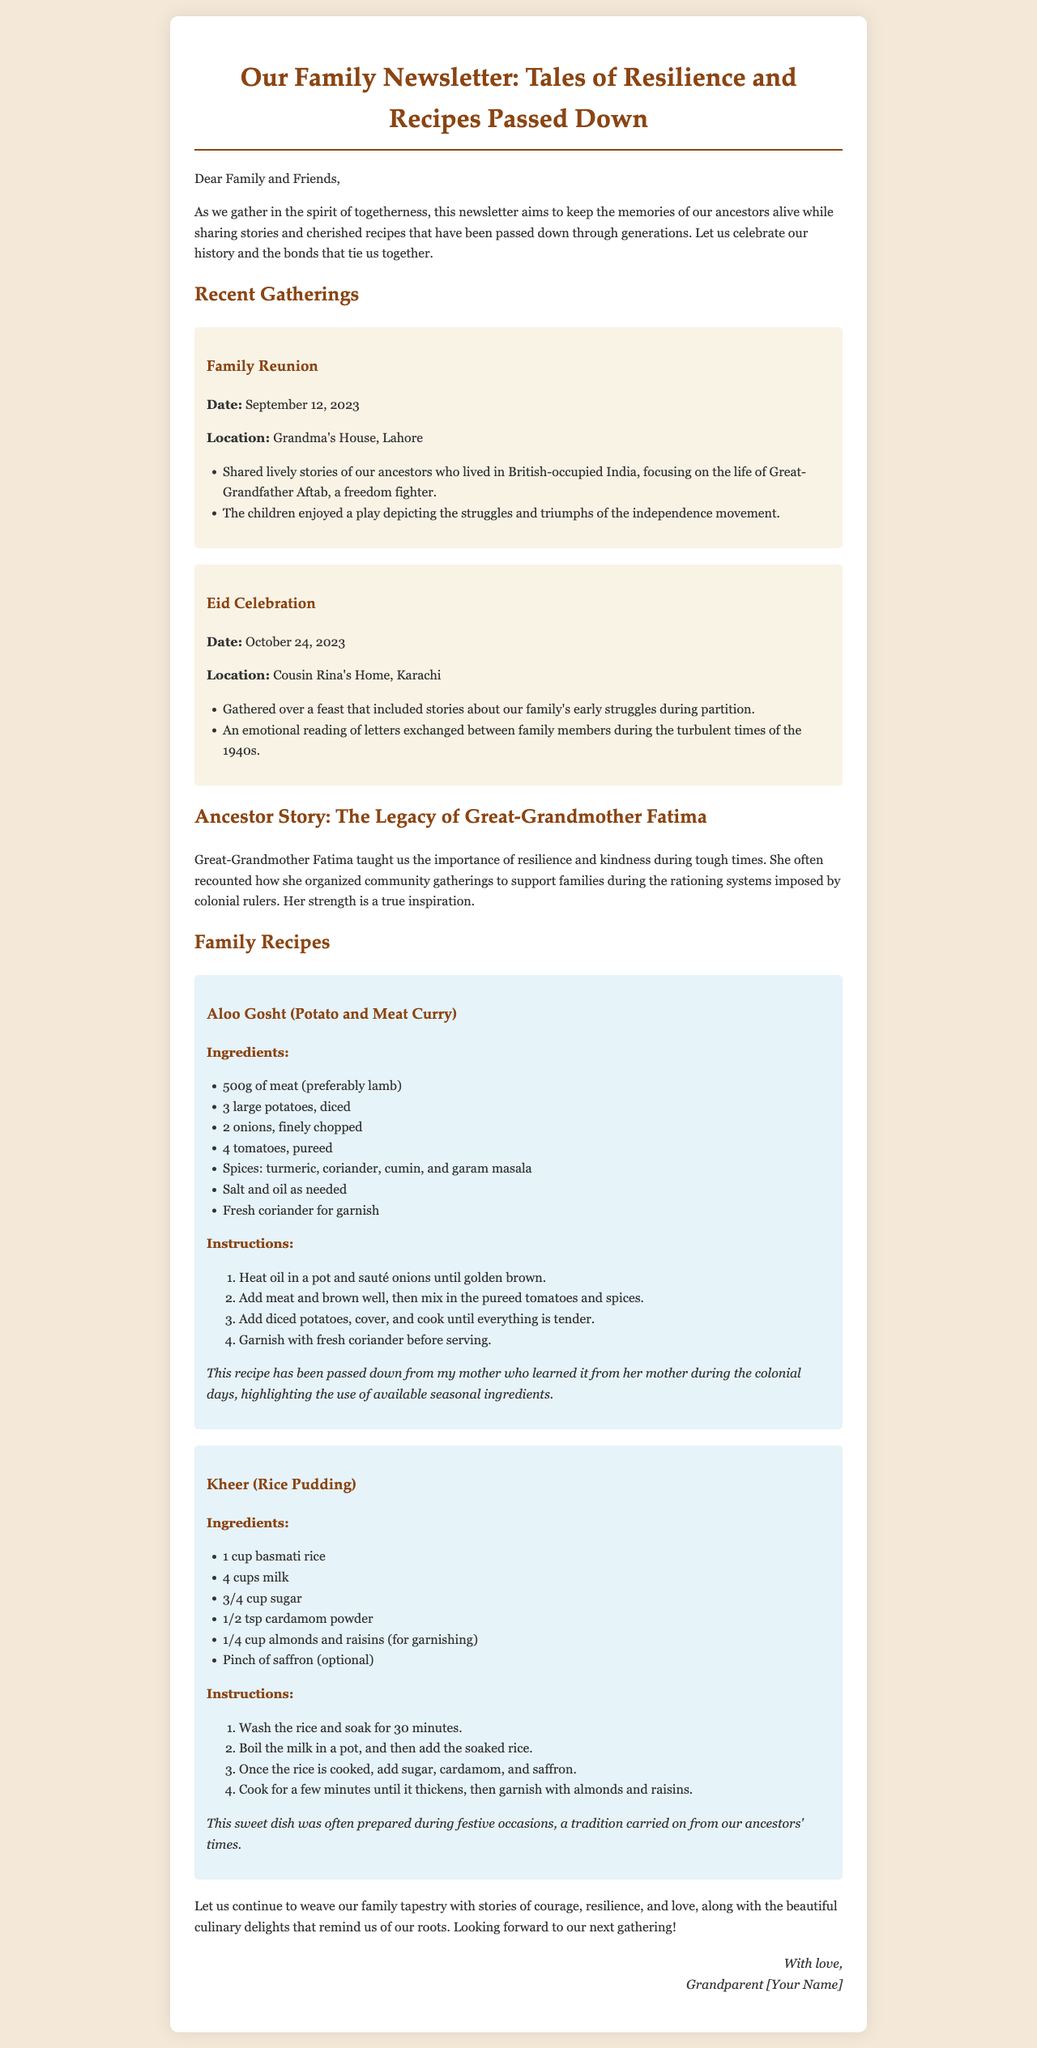what is the date of the family reunion? The family reunion is mentioned to have occurred on September 12, 2023.
Answer: September 12, 2023 where was the Eid celebration held? The Eid celebration took place at Cousin Rina's Home, Karachi.
Answer: Cousin Rina's Home, Karachi who is highlighted as a freedom fighter in the newsletter? The newsletter mentions Great-Grandfather Aftab as a freedom fighter.
Answer: Great-Grandfather Aftab what key lesson did Great-Grandmother Fatima teach? Great-Grandmother Fatima taught the importance of resilience and kindness during tough times.
Answer: resilience and kindness how many cups of milk are needed for the Kheer recipe? The Kheer recipe specifies the use of 4 cups of milk.
Answer: 4 cups what event involved a play depicting the independence movement? The family reunion included a play depicting the struggles and triumphs of the independence movement.
Answer: family reunion which dish is associated with festive occasions? Kheer is mentioned as the dish often prepared during festive occasions.
Answer: Kheer what essential ingredient is used in Aloo Gosht? The recipe for Aloo Gosht indicates that meat is an essential ingredient.
Answer: meat when is the next gathering anticipated? The newsletter concludes with a hopeful mention of looking forward to the next gathering.
Answer: next gathering 